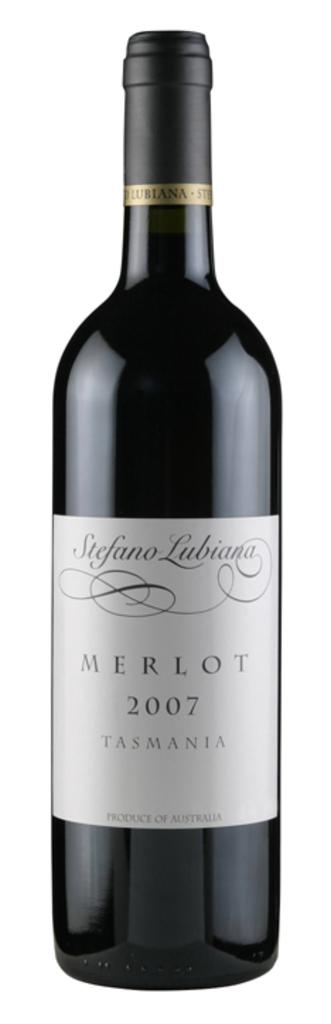<image>
Summarize the visual content of the image. A 2007 bottle of Merlot Tasmania with a white label. 